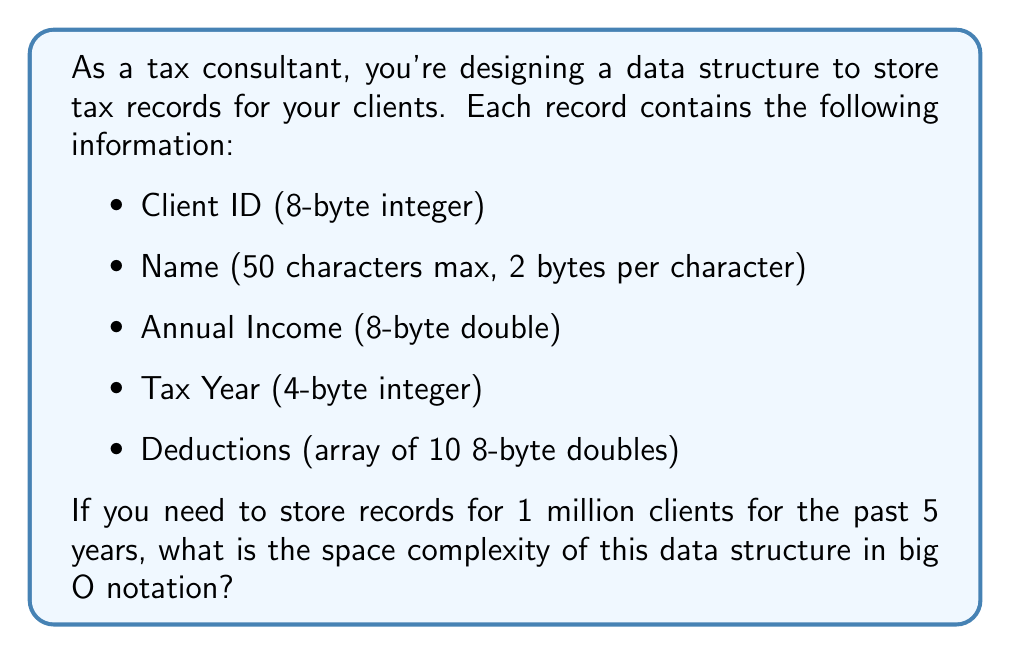Can you solve this math problem? To determine the space complexity, let's break down the problem step-by-step:

1. Calculate the size of a single tax record:
   - Client ID: 8 bytes
   - Name: 50 * 2 = 100 bytes
   - Annual Income: 8 bytes
   - Tax Year: 4 bytes
   - Deductions: 10 * 8 = 80 bytes
   
   Total size of one record: 8 + 100 + 8 + 4 + 80 = 200 bytes

2. Calculate the total number of records:
   - Number of clients: 1,000,000
   - Number of years: 5
   
   Total number of records: 1,000,000 * 5 = 5,000,000

3. Calculate the total space required:
   Space required = 200 bytes * 5,000,000 = 1,000,000,000 bytes = 1 GB

4. Express the space complexity in big O notation:
   The space required grows linearly with the number of records. If we denote the number of records as $n$, the space complexity is $O(n)$.

In this case, $n = 5,000,000$, but the actual number doesn't affect the big O notation. The important factor is that the space grows linearly with the number of records.
Answer: The space complexity of the data structure is $O(n)$, where $n$ is the total number of tax records stored. 